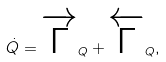<formula> <loc_0><loc_0><loc_500><loc_500>\dot { Q } = \overrightarrow { \Gamma } _ { Q } + \overleftarrow { \Gamma } _ { Q } ,</formula> 